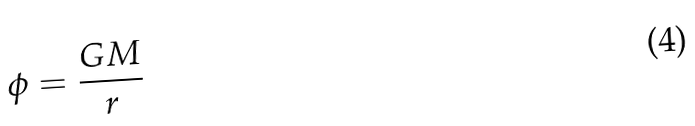<formula> <loc_0><loc_0><loc_500><loc_500>\phi = \frac { G M } { r }</formula> 